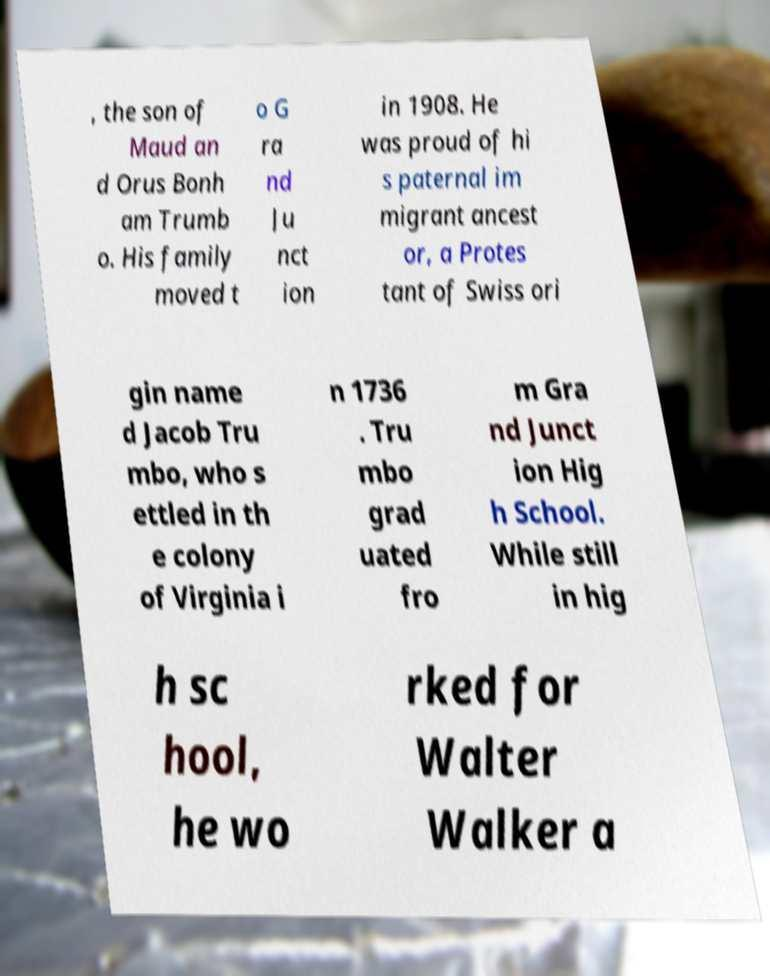Could you extract and type out the text from this image? , the son of Maud an d Orus Bonh am Trumb o. His family moved t o G ra nd Ju nct ion in 1908. He was proud of hi s paternal im migrant ancest or, a Protes tant of Swiss ori gin name d Jacob Tru mbo, who s ettled in th e colony of Virginia i n 1736 . Tru mbo grad uated fro m Gra nd Junct ion Hig h School. While still in hig h sc hool, he wo rked for Walter Walker a 